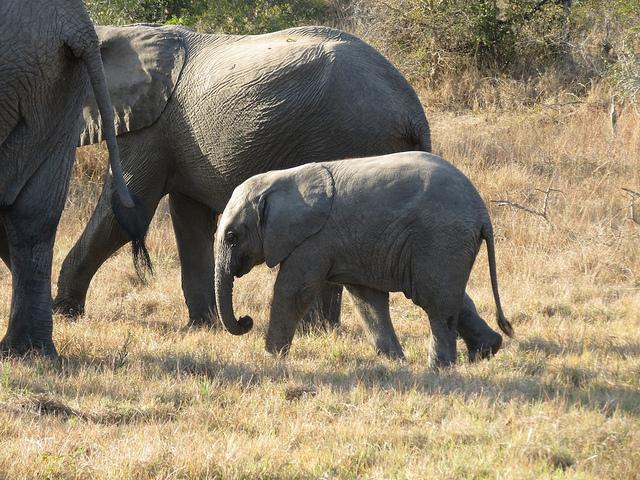How many little elephants are following behind the big elephant to the left?
Indicate the correct choice and explain in the format: 'Answer: answer
Rationale: rationale.'
Options: One, five, four, two. Answer: two.
Rationale: There are two baby elephants. 